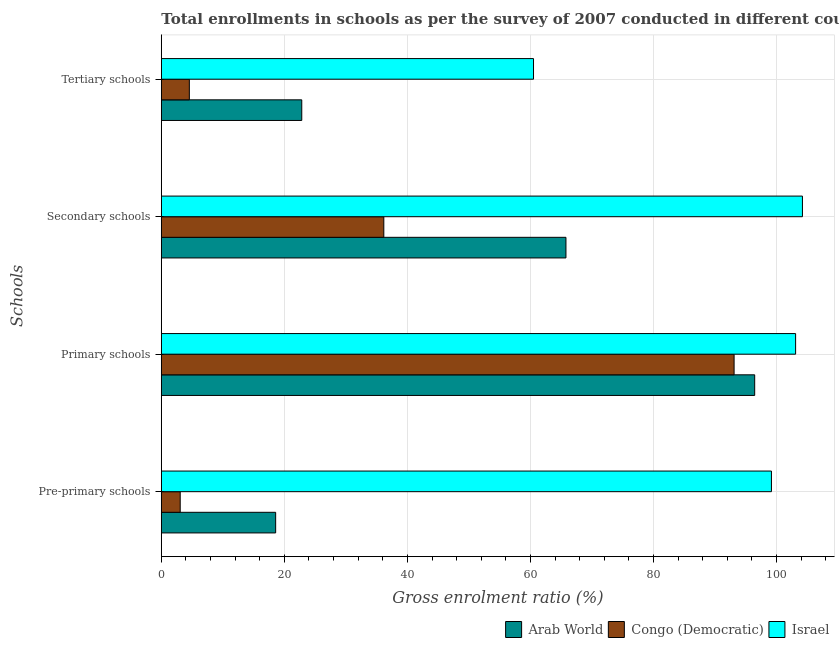How many different coloured bars are there?
Give a very brief answer. 3. How many groups of bars are there?
Provide a short and direct response. 4. Are the number of bars per tick equal to the number of legend labels?
Your answer should be very brief. Yes. Are the number of bars on each tick of the Y-axis equal?
Make the answer very short. Yes. What is the label of the 4th group of bars from the top?
Your response must be concise. Pre-primary schools. What is the gross enrolment ratio in pre-primary schools in Israel?
Provide a short and direct response. 99.18. Across all countries, what is the maximum gross enrolment ratio in pre-primary schools?
Your answer should be very brief. 99.18. Across all countries, what is the minimum gross enrolment ratio in secondary schools?
Your response must be concise. 36.17. In which country was the gross enrolment ratio in primary schools minimum?
Give a very brief answer. Congo (Democratic). What is the total gross enrolment ratio in tertiary schools in the graph?
Keep it short and to the point. 87.89. What is the difference between the gross enrolment ratio in tertiary schools in Congo (Democratic) and that in Israel?
Keep it short and to the point. -55.95. What is the difference between the gross enrolment ratio in primary schools in Arab World and the gross enrolment ratio in pre-primary schools in Congo (Democratic)?
Your answer should be very brief. 93.39. What is the average gross enrolment ratio in secondary schools per country?
Ensure brevity in your answer.  68.72. What is the difference between the gross enrolment ratio in secondary schools and gross enrolment ratio in pre-primary schools in Israel?
Provide a succinct answer. 5.04. In how many countries, is the gross enrolment ratio in tertiary schools greater than 24 %?
Your answer should be compact. 1. What is the ratio of the gross enrolment ratio in pre-primary schools in Arab World to that in Congo (Democratic)?
Offer a terse response. 6.06. Is the difference between the gross enrolment ratio in pre-primary schools in Arab World and Congo (Democratic) greater than the difference between the gross enrolment ratio in secondary schools in Arab World and Congo (Democratic)?
Offer a terse response. No. What is the difference between the highest and the second highest gross enrolment ratio in secondary schools?
Your answer should be very brief. 38.44. What is the difference between the highest and the lowest gross enrolment ratio in tertiary schools?
Keep it short and to the point. 55.95. In how many countries, is the gross enrolment ratio in primary schools greater than the average gross enrolment ratio in primary schools taken over all countries?
Give a very brief answer. 1. Is the sum of the gross enrolment ratio in pre-primary schools in Israel and Arab World greater than the maximum gross enrolment ratio in primary schools across all countries?
Ensure brevity in your answer.  Yes. What does the 3rd bar from the top in Pre-primary schools represents?
Provide a succinct answer. Arab World. What does the 1st bar from the bottom in Tertiary schools represents?
Offer a very short reply. Arab World. Are all the bars in the graph horizontal?
Your response must be concise. Yes. Where does the legend appear in the graph?
Give a very brief answer. Bottom right. How many legend labels are there?
Keep it short and to the point. 3. How are the legend labels stacked?
Give a very brief answer. Horizontal. What is the title of the graph?
Ensure brevity in your answer.  Total enrollments in schools as per the survey of 2007 conducted in different countries. Does "Tuvalu" appear as one of the legend labels in the graph?
Keep it short and to the point. No. What is the label or title of the X-axis?
Provide a succinct answer. Gross enrolment ratio (%). What is the label or title of the Y-axis?
Keep it short and to the point. Schools. What is the Gross enrolment ratio (%) in Arab World in Pre-primary schools?
Your answer should be compact. 18.59. What is the Gross enrolment ratio (%) in Congo (Democratic) in Pre-primary schools?
Offer a terse response. 3.07. What is the Gross enrolment ratio (%) of Israel in Pre-primary schools?
Provide a short and direct response. 99.18. What is the Gross enrolment ratio (%) of Arab World in Primary schools?
Offer a very short reply. 96.45. What is the Gross enrolment ratio (%) in Congo (Democratic) in Primary schools?
Your response must be concise. 93.11. What is the Gross enrolment ratio (%) in Israel in Primary schools?
Give a very brief answer. 103.11. What is the Gross enrolment ratio (%) of Arab World in Secondary schools?
Keep it short and to the point. 65.78. What is the Gross enrolment ratio (%) in Congo (Democratic) in Secondary schools?
Provide a succinct answer. 36.17. What is the Gross enrolment ratio (%) in Israel in Secondary schools?
Offer a terse response. 104.22. What is the Gross enrolment ratio (%) in Arab World in Tertiary schools?
Keep it short and to the point. 22.83. What is the Gross enrolment ratio (%) in Congo (Democratic) in Tertiary schools?
Offer a very short reply. 4.56. What is the Gross enrolment ratio (%) of Israel in Tertiary schools?
Ensure brevity in your answer.  60.5. Across all Schools, what is the maximum Gross enrolment ratio (%) of Arab World?
Provide a short and direct response. 96.45. Across all Schools, what is the maximum Gross enrolment ratio (%) in Congo (Democratic)?
Offer a terse response. 93.11. Across all Schools, what is the maximum Gross enrolment ratio (%) of Israel?
Your response must be concise. 104.22. Across all Schools, what is the minimum Gross enrolment ratio (%) in Arab World?
Offer a terse response. 18.59. Across all Schools, what is the minimum Gross enrolment ratio (%) of Congo (Democratic)?
Provide a succinct answer. 3.07. Across all Schools, what is the minimum Gross enrolment ratio (%) in Israel?
Offer a very short reply. 60.5. What is the total Gross enrolment ratio (%) of Arab World in the graph?
Your answer should be very brief. 203.65. What is the total Gross enrolment ratio (%) of Congo (Democratic) in the graph?
Your answer should be very brief. 136.9. What is the total Gross enrolment ratio (%) in Israel in the graph?
Provide a succinct answer. 367. What is the difference between the Gross enrolment ratio (%) in Arab World in Pre-primary schools and that in Primary schools?
Your answer should be compact. -77.87. What is the difference between the Gross enrolment ratio (%) in Congo (Democratic) in Pre-primary schools and that in Primary schools?
Your answer should be compact. -90.04. What is the difference between the Gross enrolment ratio (%) in Israel in Pre-primary schools and that in Primary schools?
Provide a succinct answer. -3.93. What is the difference between the Gross enrolment ratio (%) of Arab World in Pre-primary schools and that in Secondary schools?
Your answer should be compact. -47.19. What is the difference between the Gross enrolment ratio (%) in Congo (Democratic) in Pre-primary schools and that in Secondary schools?
Offer a very short reply. -33.1. What is the difference between the Gross enrolment ratio (%) in Israel in Pre-primary schools and that in Secondary schools?
Your response must be concise. -5.04. What is the difference between the Gross enrolment ratio (%) of Arab World in Pre-primary schools and that in Tertiary schools?
Make the answer very short. -4.24. What is the difference between the Gross enrolment ratio (%) of Congo (Democratic) in Pre-primary schools and that in Tertiary schools?
Your response must be concise. -1.49. What is the difference between the Gross enrolment ratio (%) in Israel in Pre-primary schools and that in Tertiary schools?
Provide a short and direct response. 38.68. What is the difference between the Gross enrolment ratio (%) in Arab World in Primary schools and that in Secondary schools?
Ensure brevity in your answer.  30.68. What is the difference between the Gross enrolment ratio (%) in Congo (Democratic) in Primary schools and that in Secondary schools?
Keep it short and to the point. 56.94. What is the difference between the Gross enrolment ratio (%) in Israel in Primary schools and that in Secondary schools?
Your answer should be compact. -1.11. What is the difference between the Gross enrolment ratio (%) in Arab World in Primary schools and that in Tertiary schools?
Your answer should be compact. 73.62. What is the difference between the Gross enrolment ratio (%) of Congo (Democratic) in Primary schools and that in Tertiary schools?
Ensure brevity in your answer.  88.55. What is the difference between the Gross enrolment ratio (%) in Israel in Primary schools and that in Tertiary schools?
Keep it short and to the point. 42.6. What is the difference between the Gross enrolment ratio (%) of Arab World in Secondary schools and that in Tertiary schools?
Your answer should be compact. 42.95. What is the difference between the Gross enrolment ratio (%) in Congo (Democratic) in Secondary schools and that in Tertiary schools?
Make the answer very short. 31.61. What is the difference between the Gross enrolment ratio (%) of Israel in Secondary schools and that in Tertiary schools?
Give a very brief answer. 43.71. What is the difference between the Gross enrolment ratio (%) in Arab World in Pre-primary schools and the Gross enrolment ratio (%) in Congo (Democratic) in Primary schools?
Your answer should be compact. -74.52. What is the difference between the Gross enrolment ratio (%) in Arab World in Pre-primary schools and the Gross enrolment ratio (%) in Israel in Primary schools?
Give a very brief answer. -84.52. What is the difference between the Gross enrolment ratio (%) of Congo (Democratic) in Pre-primary schools and the Gross enrolment ratio (%) of Israel in Primary schools?
Your answer should be compact. -100.04. What is the difference between the Gross enrolment ratio (%) in Arab World in Pre-primary schools and the Gross enrolment ratio (%) in Congo (Democratic) in Secondary schools?
Your response must be concise. -17.58. What is the difference between the Gross enrolment ratio (%) of Arab World in Pre-primary schools and the Gross enrolment ratio (%) of Israel in Secondary schools?
Your answer should be compact. -85.63. What is the difference between the Gross enrolment ratio (%) of Congo (Democratic) in Pre-primary schools and the Gross enrolment ratio (%) of Israel in Secondary schools?
Provide a short and direct response. -101.15. What is the difference between the Gross enrolment ratio (%) in Arab World in Pre-primary schools and the Gross enrolment ratio (%) in Congo (Democratic) in Tertiary schools?
Offer a terse response. 14.03. What is the difference between the Gross enrolment ratio (%) in Arab World in Pre-primary schools and the Gross enrolment ratio (%) in Israel in Tertiary schools?
Offer a very short reply. -41.91. What is the difference between the Gross enrolment ratio (%) of Congo (Democratic) in Pre-primary schools and the Gross enrolment ratio (%) of Israel in Tertiary schools?
Provide a succinct answer. -57.43. What is the difference between the Gross enrolment ratio (%) in Arab World in Primary schools and the Gross enrolment ratio (%) in Congo (Democratic) in Secondary schools?
Your answer should be compact. 60.29. What is the difference between the Gross enrolment ratio (%) of Arab World in Primary schools and the Gross enrolment ratio (%) of Israel in Secondary schools?
Keep it short and to the point. -7.76. What is the difference between the Gross enrolment ratio (%) in Congo (Democratic) in Primary schools and the Gross enrolment ratio (%) in Israel in Secondary schools?
Offer a very short reply. -11.11. What is the difference between the Gross enrolment ratio (%) in Arab World in Primary schools and the Gross enrolment ratio (%) in Congo (Democratic) in Tertiary schools?
Your answer should be compact. 91.9. What is the difference between the Gross enrolment ratio (%) in Arab World in Primary schools and the Gross enrolment ratio (%) in Israel in Tertiary schools?
Offer a terse response. 35.95. What is the difference between the Gross enrolment ratio (%) in Congo (Democratic) in Primary schools and the Gross enrolment ratio (%) in Israel in Tertiary schools?
Your response must be concise. 32.61. What is the difference between the Gross enrolment ratio (%) in Arab World in Secondary schools and the Gross enrolment ratio (%) in Congo (Democratic) in Tertiary schools?
Offer a terse response. 61.22. What is the difference between the Gross enrolment ratio (%) in Arab World in Secondary schools and the Gross enrolment ratio (%) in Israel in Tertiary schools?
Keep it short and to the point. 5.27. What is the difference between the Gross enrolment ratio (%) in Congo (Democratic) in Secondary schools and the Gross enrolment ratio (%) in Israel in Tertiary schools?
Offer a terse response. -24.33. What is the average Gross enrolment ratio (%) in Arab World per Schools?
Offer a very short reply. 50.91. What is the average Gross enrolment ratio (%) in Congo (Democratic) per Schools?
Ensure brevity in your answer.  34.23. What is the average Gross enrolment ratio (%) of Israel per Schools?
Offer a very short reply. 91.75. What is the difference between the Gross enrolment ratio (%) of Arab World and Gross enrolment ratio (%) of Congo (Democratic) in Pre-primary schools?
Make the answer very short. 15.52. What is the difference between the Gross enrolment ratio (%) of Arab World and Gross enrolment ratio (%) of Israel in Pre-primary schools?
Your answer should be compact. -80.59. What is the difference between the Gross enrolment ratio (%) of Congo (Democratic) and Gross enrolment ratio (%) of Israel in Pre-primary schools?
Provide a succinct answer. -96.11. What is the difference between the Gross enrolment ratio (%) of Arab World and Gross enrolment ratio (%) of Congo (Democratic) in Primary schools?
Offer a very short reply. 3.35. What is the difference between the Gross enrolment ratio (%) of Arab World and Gross enrolment ratio (%) of Israel in Primary schools?
Your answer should be compact. -6.65. What is the difference between the Gross enrolment ratio (%) of Congo (Democratic) and Gross enrolment ratio (%) of Israel in Primary schools?
Your answer should be very brief. -10. What is the difference between the Gross enrolment ratio (%) of Arab World and Gross enrolment ratio (%) of Congo (Democratic) in Secondary schools?
Offer a terse response. 29.61. What is the difference between the Gross enrolment ratio (%) in Arab World and Gross enrolment ratio (%) in Israel in Secondary schools?
Keep it short and to the point. -38.44. What is the difference between the Gross enrolment ratio (%) in Congo (Democratic) and Gross enrolment ratio (%) in Israel in Secondary schools?
Give a very brief answer. -68.05. What is the difference between the Gross enrolment ratio (%) of Arab World and Gross enrolment ratio (%) of Congo (Democratic) in Tertiary schools?
Your answer should be compact. 18.27. What is the difference between the Gross enrolment ratio (%) in Arab World and Gross enrolment ratio (%) in Israel in Tertiary schools?
Provide a short and direct response. -37.67. What is the difference between the Gross enrolment ratio (%) of Congo (Democratic) and Gross enrolment ratio (%) of Israel in Tertiary schools?
Offer a terse response. -55.95. What is the ratio of the Gross enrolment ratio (%) of Arab World in Pre-primary schools to that in Primary schools?
Your response must be concise. 0.19. What is the ratio of the Gross enrolment ratio (%) of Congo (Democratic) in Pre-primary schools to that in Primary schools?
Offer a terse response. 0.03. What is the ratio of the Gross enrolment ratio (%) of Israel in Pre-primary schools to that in Primary schools?
Your response must be concise. 0.96. What is the ratio of the Gross enrolment ratio (%) in Arab World in Pre-primary schools to that in Secondary schools?
Offer a terse response. 0.28. What is the ratio of the Gross enrolment ratio (%) of Congo (Democratic) in Pre-primary schools to that in Secondary schools?
Offer a terse response. 0.08. What is the ratio of the Gross enrolment ratio (%) of Israel in Pre-primary schools to that in Secondary schools?
Provide a short and direct response. 0.95. What is the ratio of the Gross enrolment ratio (%) of Arab World in Pre-primary schools to that in Tertiary schools?
Provide a short and direct response. 0.81. What is the ratio of the Gross enrolment ratio (%) of Congo (Democratic) in Pre-primary schools to that in Tertiary schools?
Give a very brief answer. 0.67. What is the ratio of the Gross enrolment ratio (%) of Israel in Pre-primary schools to that in Tertiary schools?
Keep it short and to the point. 1.64. What is the ratio of the Gross enrolment ratio (%) of Arab World in Primary schools to that in Secondary schools?
Provide a short and direct response. 1.47. What is the ratio of the Gross enrolment ratio (%) of Congo (Democratic) in Primary schools to that in Secondary schools?
Your response must be concise. 2.57. What is the ratio of the Gross enrolment ratio (%) in Israel in Primary schools to that in Secondary schools?
Offer a terse response. 0.99. What is the ratio of the Gross enrolment ratio (%) in Arab World in Primary schools to that in Tertiary schools?
Your response must be concise. 4.22. What is the ratio of the Gross enrolment ratio (%) of Congo (Democratic) in Primary schools to that in Tertiary schools?
Provide a succinct answer. 20.43. What is the ratio of the Gross enrolment ratio (%) of Israel in Primary schools to that in Tertiary schools?
Provide a succinct answer. 1.7. What is the ratio of the Gross enrolment ratio (%) in Arab World in Secondary schools to that in Tertiary schools?
Offer a terse response. 2.88. What is the ratio of the Gross enrolment ratio (%) of Congo (Democratic) in Secondary schools to that in Tertiary schools?
Ensure brevity in your answer.  7.94. What is the ratio of the Gross enrolment ratio (%) of Israel in Secondary schools to that in Tertiary schools?
Ensure brevity in your answer.  1.72. What is the difference between the highest and the second highest Gross enrolment ratio (%) in Arab World?
Your response must be concise. 30.68. What is the difference between the highest and the second highest Gross enrolment ratio (%) of Congo (Democratic)?
Offer a terse response. 56.94. What is the difference between the highest and the second highest Gross enrolment ratio (%) of Israel?
Offer a very short reply. 1.11. What is the difference between the highest and the lowest Gross enrolment ratio (%) of Arab World?
Provide a short and direct response. 77.87. What is the difference between the highest and the lowest Gross enrolment ratio (%) in Congo (Democratic)?
Keep it short and to the point. 90.04. What is the difference between the highest and the lowest Gross enrolment ratio (%) of Israel?
Ensure brevity in your answer.  43.71. 